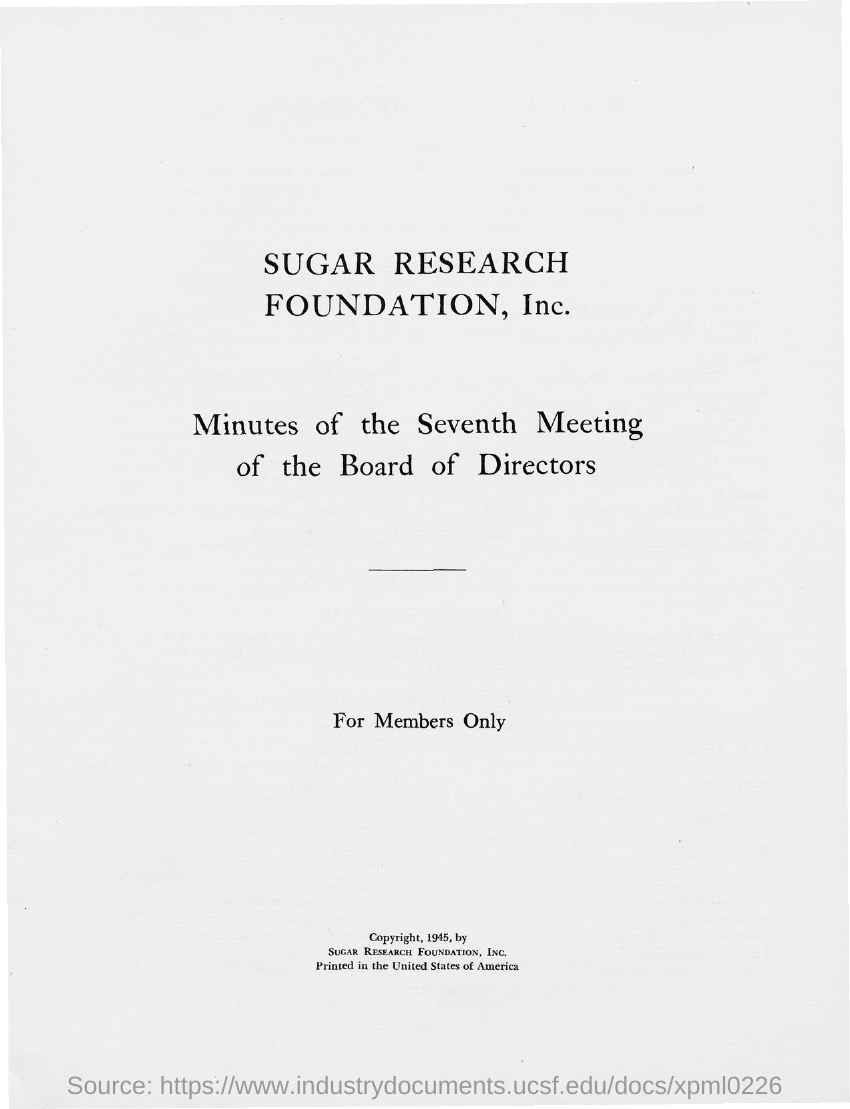Who holds the copyright ?
Provide a succinct answer. Sugar Research Foundation, Inc. 